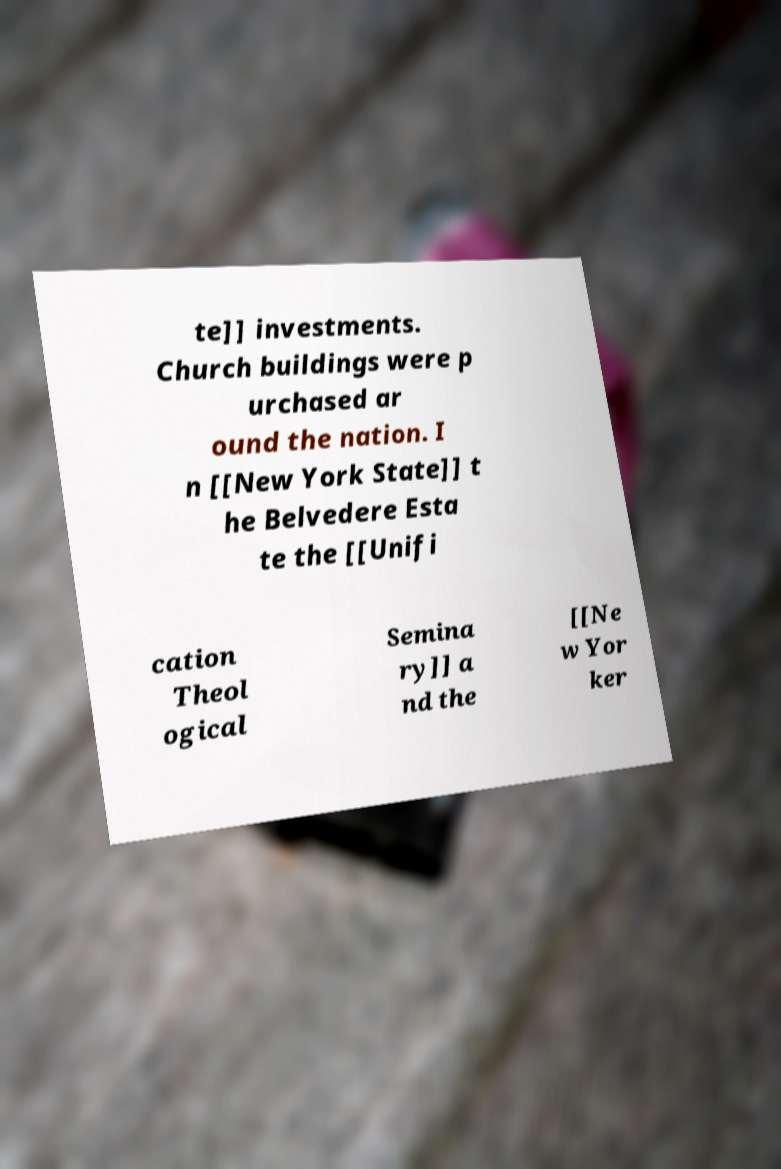I need the written content from this picture converted into text. Can you do that? te]] investments. Church buildings were p urchased ar ound the nation. I n [[New York State]] t he Belvedere Esta te the [[Unifi cation Theol ogical Semina ry]] a nd the [[Ne w Yor ker 